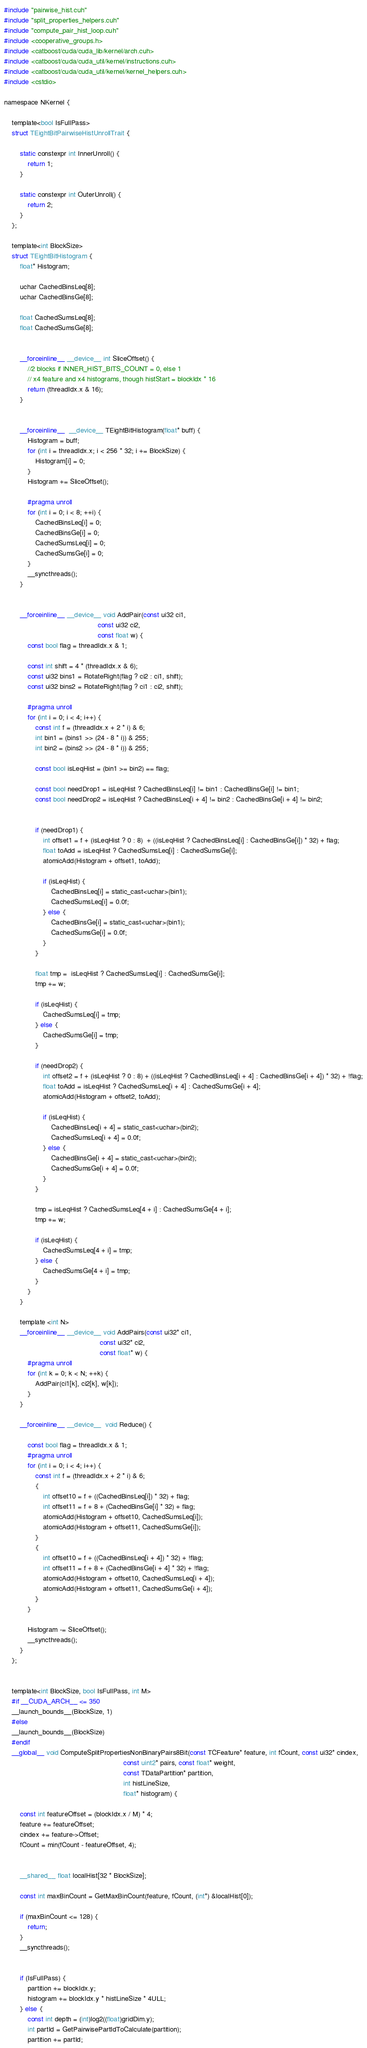Convert code to text. <code><loc_0><loc_0><loc_500><loc_500><_Cuda_>#include "pairwise_hist.cuh"
#include "split_properties_helpers.cuh"
#include "compute_pair_hist_loop.cuh"
#include <cooperative_groups.h>
#include <catboost/cuda/cuda_lib/kernel/arch.cuh>
#include <catboost/cuda/cuda_util/kernel/instructions.cuh>
#include <catboost/cuda/cuda_util/kernel/kernel_helpers.cuh>
#include <cstdio>

namespace NKernel {

    template<bool IsFullPass>
    struct TEightBitPairwiseHistUnrollTrait {

        static constexpr int InnerUnroll() {
            return 1;
        }

        static constexpr int OuterUnroll() {
            return 2;
        }
    };

    template<int BlockSize>
    struct TEightBitHistogram {
        float* Histogram;

        uchar CachedBinsLeq[8];
        uchar CachedBinsGe[8];

        float CachedSumsLeq[8];
        float CachedSumsGe[8];


        __forceinline__ __device__ int SliceOffset() {
            //2 blocks if INNER_HIST_BITS_COUNT = 0, else 1
            // x4 feature and x4 histograms, though histStart = blockIdx * 16
            return (threadIdx.x & 16);
        }


        __forceinline__  __device__ TEightBitHistogram(float* buff) {
            Histogram = buff;
            for (int i = threadIdx.x; i < 256 * 32; i += BlockSize) {
                Histogram[i] = 0;
            }
            Histogram += SliceOffset();

            #pragma unroll
            for (int i = 0; i < 8; ++i) {
                CachedBinsLeq[i] = 0;
                CachedBinsGe[i] = 0;
                CachedSumsLeq[i] = 0;
                CachedSumsGe[i] = 0;
            }
            __syncthreads();
        }


        __forceinline__ __device__ void AddPair(const ui32 ci1,
                                                const ui32 ci2,
                                                const float w) {
            const bool flag = threadIdx.x & 1;

            const int shift = 4 * (threadIdx.x & 6);
            const ui32 bins1 = RotateRight(flag ? ci2 : ci1, shift);
            const ui32 bins2 = RotateRight(flag ? ci1 : ci2, shift);

            #pragma unroll
            for (int i = 0; i < 4; i++) {
                const int f = (threadIdx.x + 2 * i) & 6;
                int bin1 = (bins1 >> (24 - 8 * i)) & 255;
                int bin2 = (bins2 >> (24 - 8 * i)) & 255;

                const bool isLeqHist = (bin1 >= bin2) == flag;

                const bool needDrop1 = isLeqHist ? CachedBinsLeq[i] != bin1 : CachedBinsGe[i] != bin1;
                const bool needDrop2 = isLeqHist ? CachedBinsLeq[i + 4] != bin2 : CachedBinsGe[i + 4] != bin2;


                if (needDrop1) {
                    int offset1 = f + (isLeqHist ? 0 : 8)  + ((isLeqHist ? CachedBinsLeq[i] : CachedBinsGe[i]) * 32) + flag;
                    float toAdd = isLeqHist ? CachedSumsLeq[i] : CachedSumsGe[i];
                    atomicAdd(Histogram + offset1, toAdd);

                    if (isLeqHist) {
                        CachedBinsLeq[i] = static_cast<uchar>(bin1);
                        CachedSumsLeq[i] = 0.0f;
                    } else {
                        CachedBinsGe[i] = static_cast<uchar>(bin1);
                        CachedSumsGe[i] = 0.0f;
                    }
                }

                float tmp =  isLeqHist ? CachedSumsLeq[i] : CachedSumsGe[i];
                tmp += w;

                if (isLeqHist) {
                    CachedSumsLeq[i] = tmp;
                } else {
                    CachedSumsGe[i] = tmp;
                }

                if (needDrop2) {
                    int offset2 = f + (isLeqHist ? 0 : 8) + ((isLeqHist ? CachedBinsLeq[i + 4] : CachedBinsGe[i + 4]) * 32) + !flag;
                    float toAdd = isLeqHist ? CachedSumsLeq[i + 4] : CachedSumsGe[i + 4];
                    atomicAdd(Histogram + offset2, toAdd);

                    if (isLeqHist) {
                        CachedBinsLeq[i + 4] = static_cast<uchar>(bin2);
                        CachedSumsLeq[i + 4] = 0.0f;
                    } else {
                        CachedBinsGe[i + 4] = static_cast<uchar>(bin2);
                        CachedSumsGe[i + 4] = 0.0f;
                    }
                }

                tmp = isLeqHist ? CachedSumsLeq[4 + i] : CachedSumsGe[4 + i];
                tmp += w;

                if (isLeqHist) {
                    CachedSumsLeq[4 + i] = tmp;
                } else {
                    CachedSumsGe[4 + i] = tmp;
                }
            }
        }

        template <int N>
        __forceinline__ __device__ void AddPairs(const ui32* ci1,
                                                 const ui32* ci2,
                                                 const float* w) {
            #pragma unroll
            for (int k = 0; k < N; ++k) {
                AddPair(ci1[k], ci2[k], w[k]);
            }
        }

        __forceinline__ __device__  void Reduce() {

            const bool flag = threadIdx.x & 1;
            #pragma unroll
            for (int i = 0; i < 4; i++) {
                const int f = (threadIdx.x + 2 * i) & 6;
                {
                    int offset10 = f + ((CachedBinsLeq[i]) * 32) + flag;
                    int offset11 = f + 8 + (CachedBinsGe[i] * 32) + flag;
                    atomicAdd(Histogram + offset10, CachedSumsLeq[i]);
                    atomicAdd(Histogram + offset11, CachedSumsGe[i]);
                }
                {
                    int offset10 = f + ((CachedBinsLeq[i + 4]) * 32) + !flag;
                    int offset11 = f + 8 + (CachedBinsGe[i + 4] * 32) + !flag;
                    atomicAdd(Histogram + offset10, CachedSumsLeq[i + 4]);
                    atomicAdd(Histogram + offset11, CachedSumsGe[i + 4]);
                }
            }

            Histogram -= SliceOffset();
            __syncthreads();
        }
    };


    template<int BlockSize, bool IsFullPass, int M>
    #if __CUDA_ARCH__ <= 350
    __launch_bounds__(BlockSize, 1)
    #else
    __launch_bounds__(BlockSize)
    #endif
    __global__ void ComputeSplitPropertiesNonBinaryPairs8Bit(const TCFeature* feature, int fCount, const ui32* cindex,
                                                             const uint2* pairs, const float* weight,
                                                             const TDataPartition* partition,
                                                             int histLineSize,
                                                             float* histogram) {

        const int featureOffset = (blockIdx.x / M) * 4;
        feature += featureOffset;
        cindex += feature->Offset;
        fCount = min(fCount - featureOffset, 4);


        __shared__ float localHist[32 * BlockSize];

        const int maxBinCount = GetMaxBinCount(feature, fCount, (int*) &localHist[0]);

        if (maxBinCount <= 128) {
            return;
        }
        __syncthreads();


        if (IsFullPass) {
            partition += blockIdx.y;
            histogram += blockIdx.y * histLineSize * 4ULL;
        } else {
            const int depth = (int)log2((float)gridDim.y);
            int partId = GetPairwisePartIdToCalculate(partition);
            partition += partId;</code> 